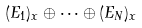Convert formula to latex. <formula><loc_0><loc_0><loc_500><loc_500>( E _ { 1 } ) _ { x } \oplus \cdots \oplus ( E _ { N } ) _ { x }</formula> 